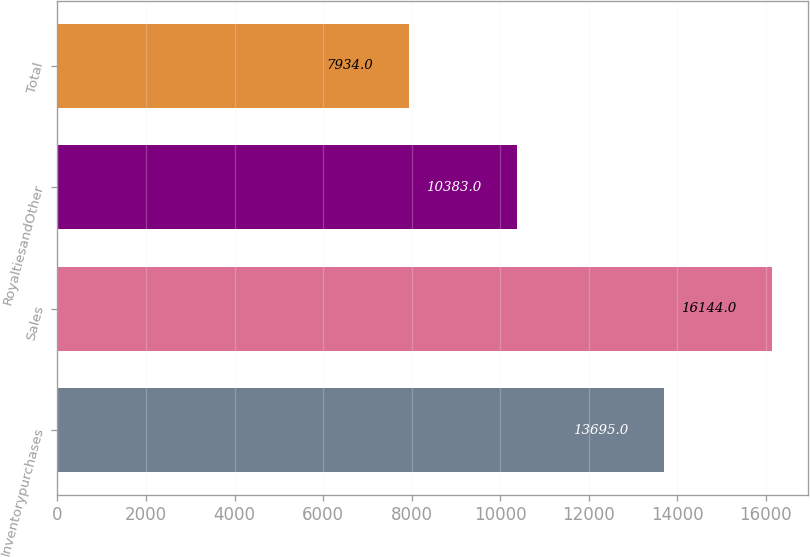Convert chart to OTSL. <chart><loc_0><loc_0><loc_500><loc_500><bar_chart><fcel>Inventorypurchases<fcel>Sales<fcel>RoyaltiesandOther<fcel>Total<nl><fcel>13695<fcel>16144<fcel>10383<fcel>7934<nl></chart> 